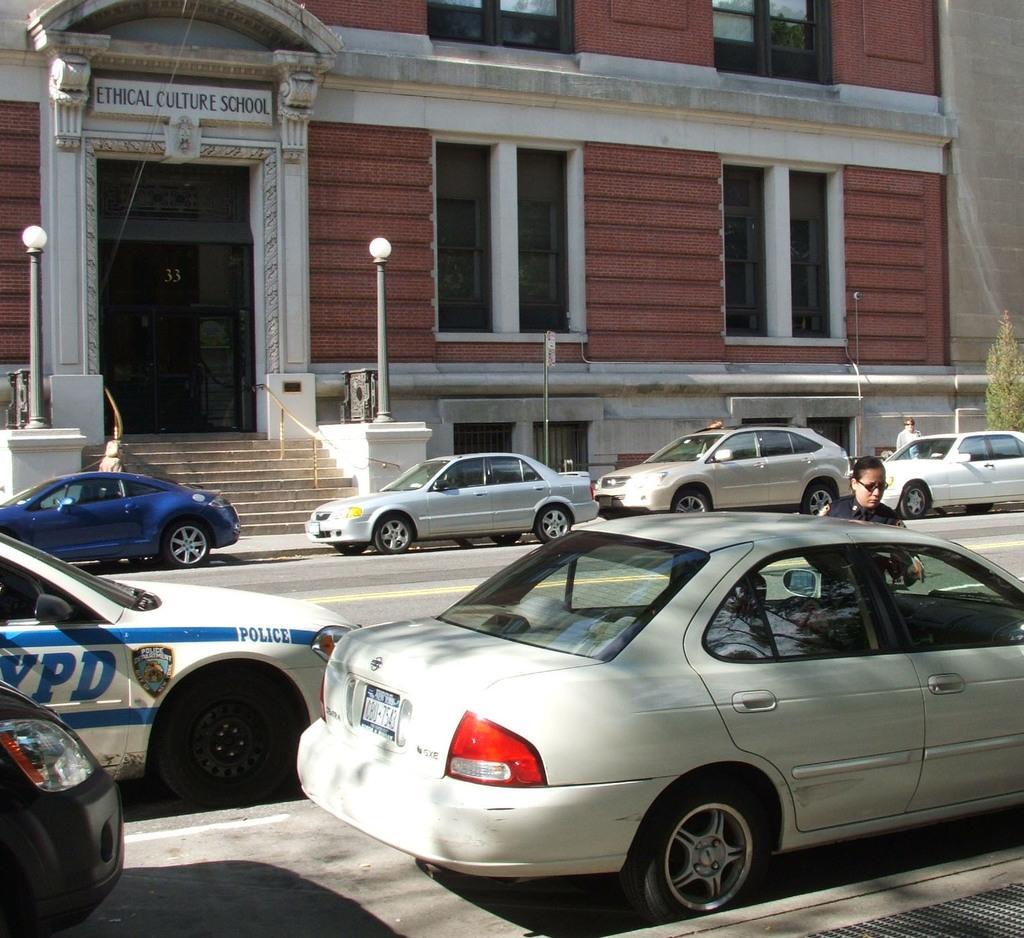Can you describe this image briefly? This picture is clicked outside. In the center we can see the group of vehicles seems to be parked on the ground and we can see the two persons. In the background there is a building and we can see the lamps attached to the poles and the windows of the building. 